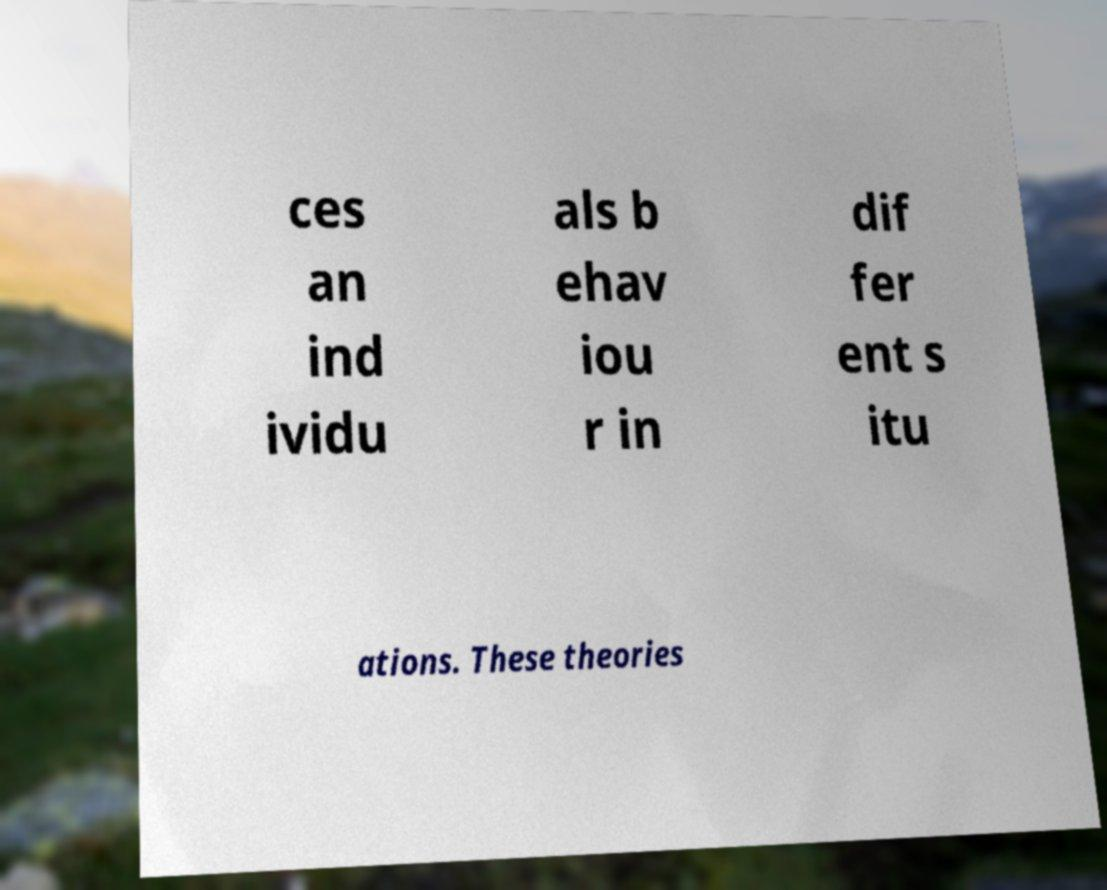I need the written content from this picture converted into text. Can you do that? ces an ind ividu als b ehav iou r in dif fer ent s itu ations. These theories 